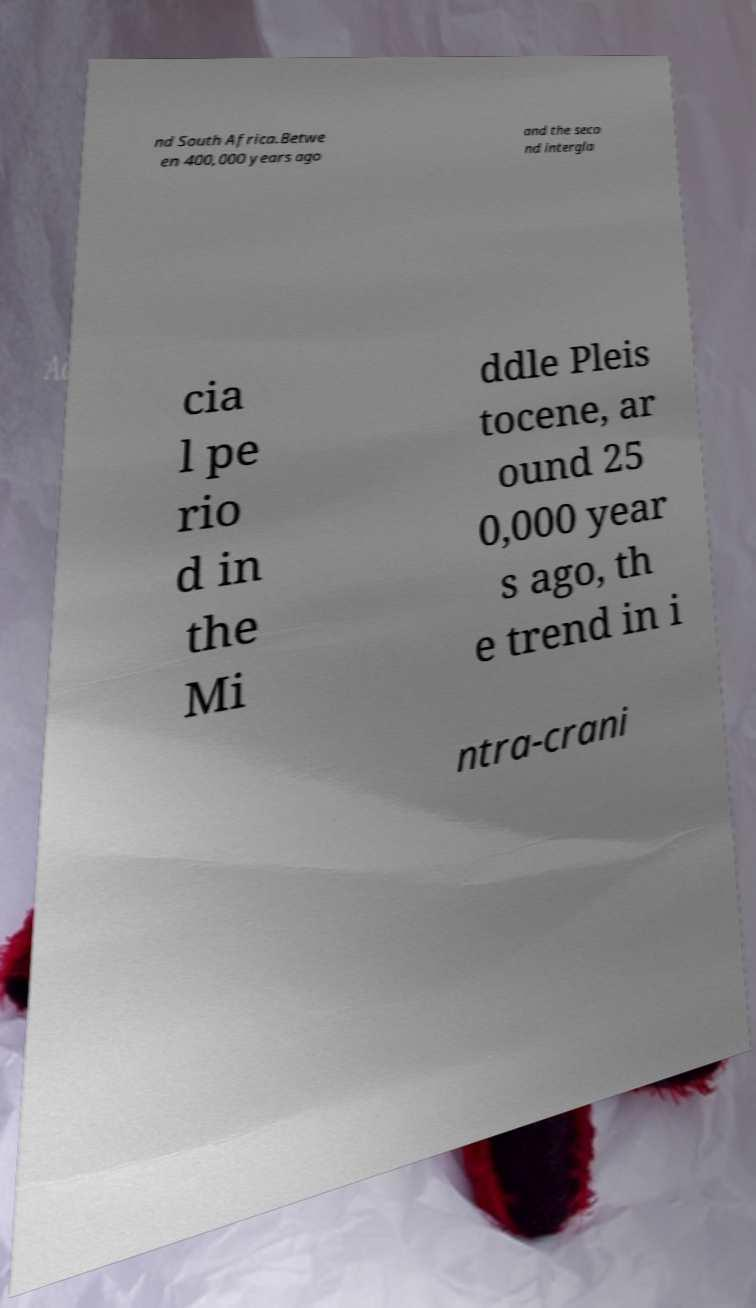Could you assist in decoding the text presented in this image and type it out clearly? nd South Africa.Betwe en 400,000 years ago and the seco nd intergla cia l pe rio d in the Mi ddle Pleis tocene, ar ound 25 0,000 year s ago, th e trend in i ntra-crani 